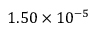Convert formula to latex. <formula><loc_0><loc_0><loc_500><loc_500>1 . 5 0 \times 1 0 ^ { - 5 }</formula> 